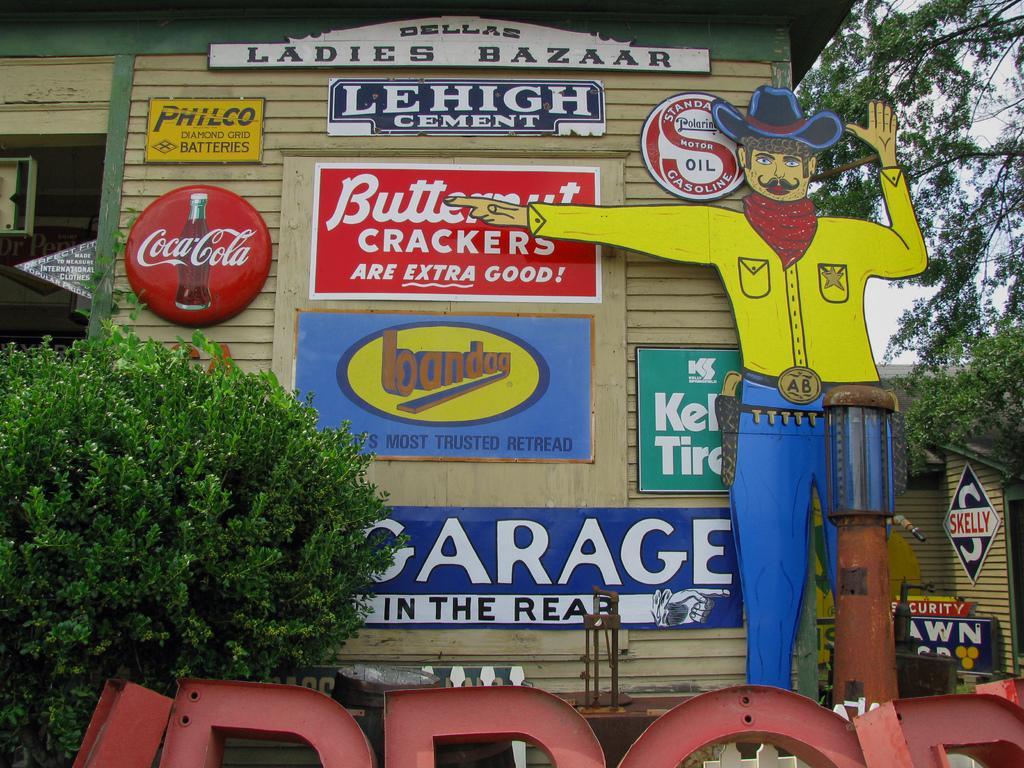In one or two sentences, can you explain what this image depicts? In the image we can see there is a building and there are banners on the building. There is a cartoon statue of a cow boy, he is wearing scarf around his neck and wearing hat and he is showing direction towards the building. There are plants outside the building and behind there is a tree and there is a building. 